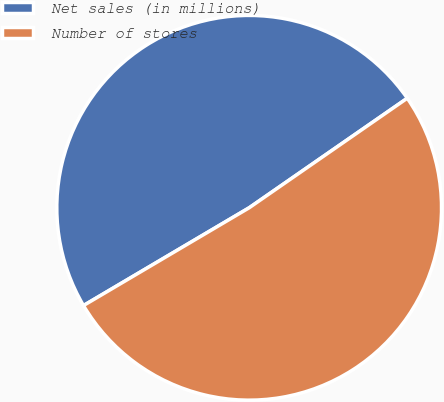Convert chart to OTSL. <chart><loc_0><loc_0><loc_500><loc_500><pie_chart><fcel>Net sales (in millions)<fcel>Number of stores<nl><fcel>48.84%<fcel>51.16%<nl></chart> 